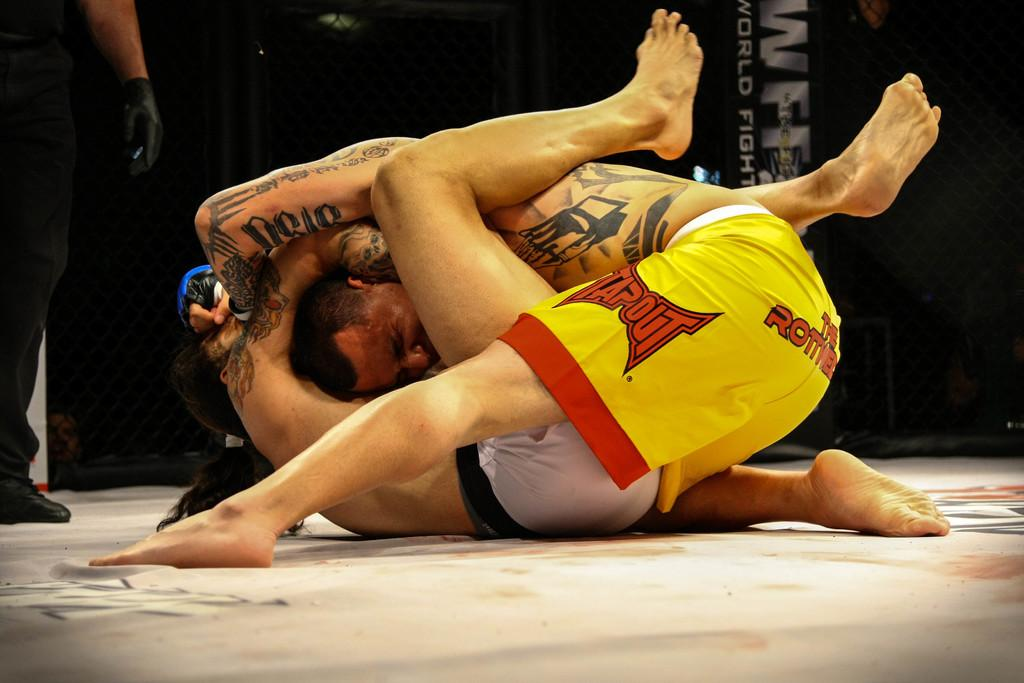<image>
Describe the image concisely. MMA fighters fighting with one who's shorts say Tapout. 